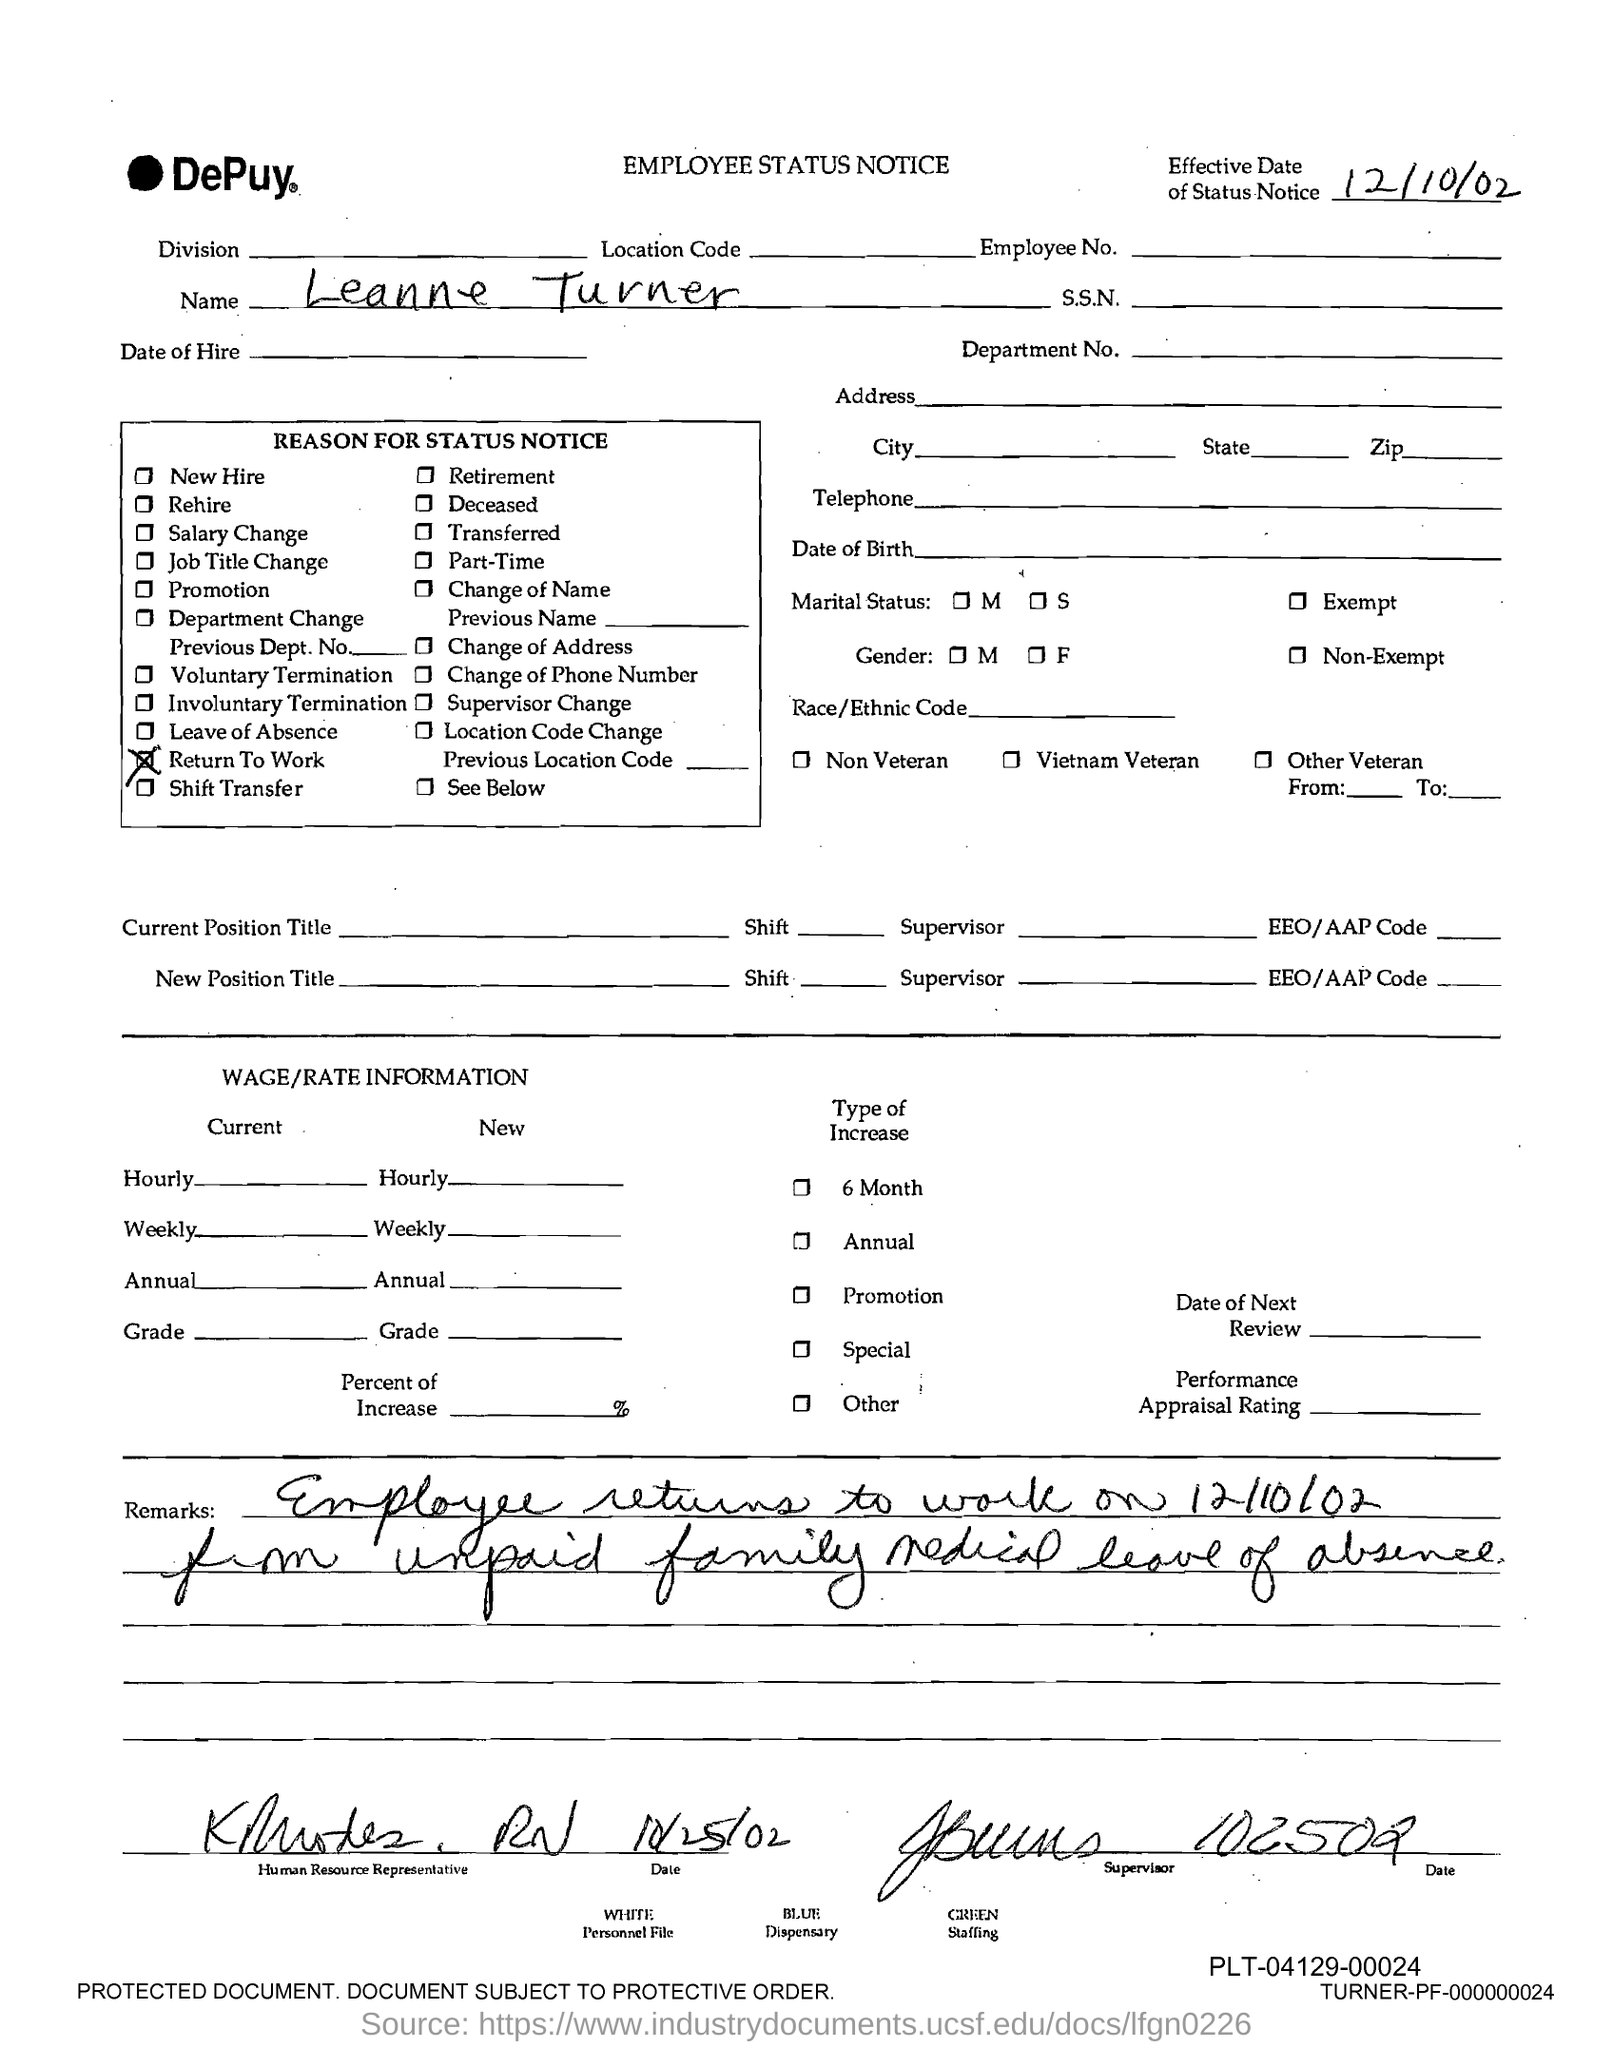Point out several critical features in this image. The name of the person mentioned in the document is Leanne Turner. 